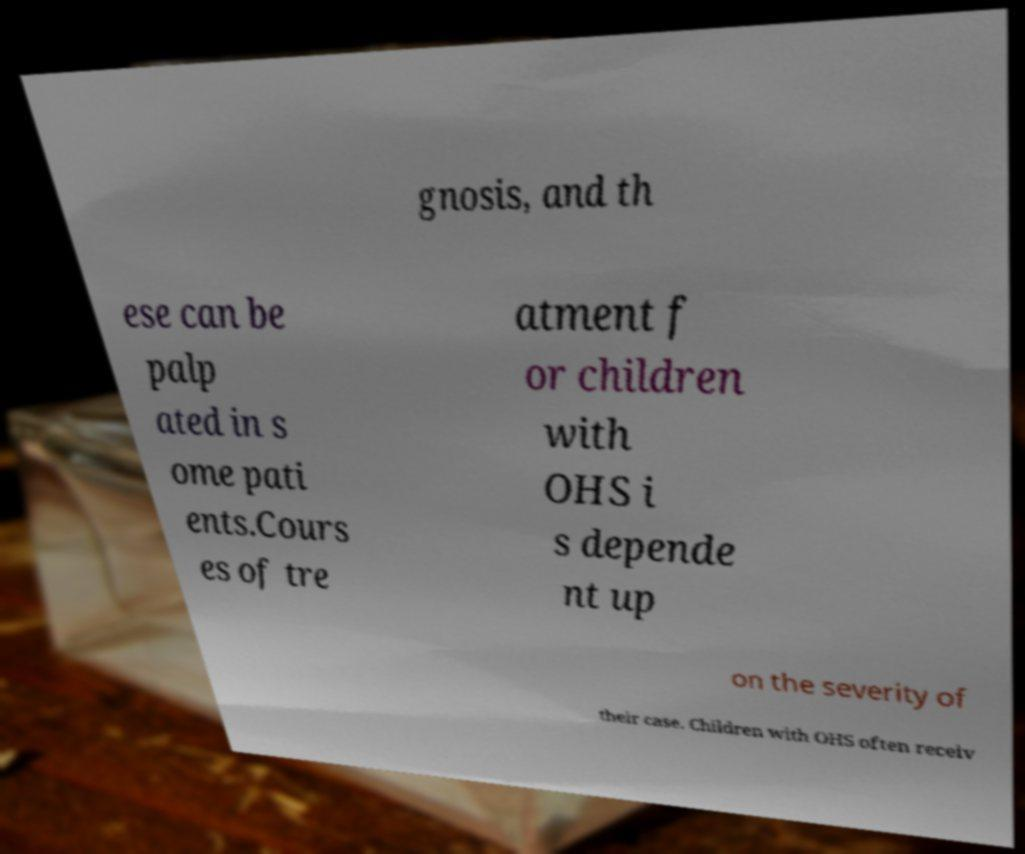There's text embedded in this image that I need extracted. Can you transcribe it verbatim? gnosis, and th ese can be palp ated in s ome pati ents.Cours es of tre atment f or children with OHS i s depende nt up on the severity of their case. Children with OHS often receiv 